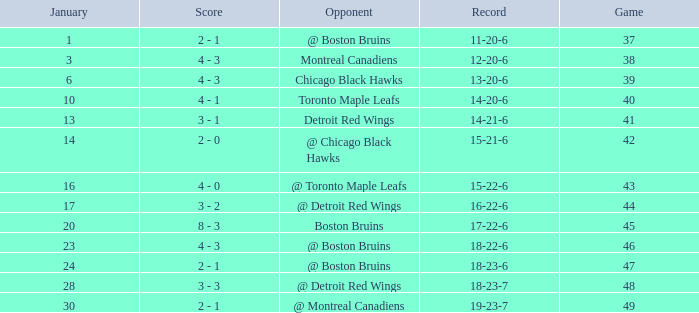How many games were played in total on january 20? 1.0. 